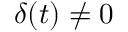Convert formula to latex. <formula><loc_0><loc_0><loc_500><loc_500>\delta ( t ) \neq 0</formula> 